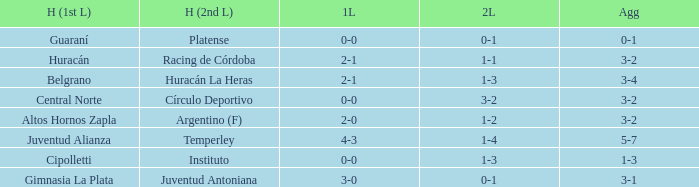Which team played the 2nd leg at home with a tie of 1-1 and scored 3-2 in aggregate? Racing de Córdoba. 